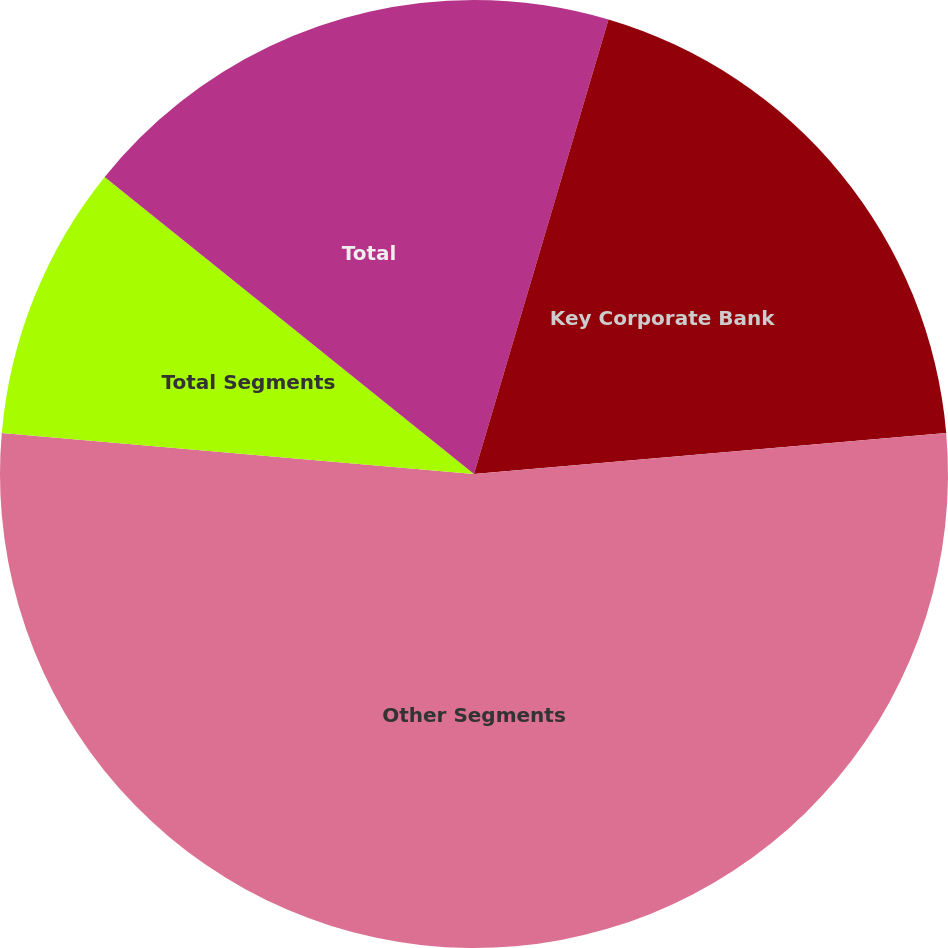Convert chart to OTSL. <chart><loc_0><loc_0><loc_500><loc_500><pie_chart><fcel>Key Community Bank<fcel>Key Corporate Bank<fcel>Other Segments<fcel>Total Segments<fcel>Total<nl><fcel>4.58%<fcel>19.04%<fcel>52.77%<fcel>9.4%<fcel>14.22%<nl></chart> 